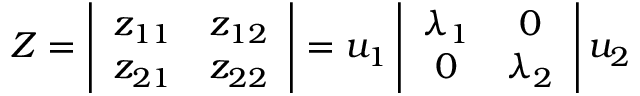<formula> <loc_0><loc_0><loc_500><loc_500>Z = \left | \begin{array} { c c } { { z _ { 1 1 } } } & { { z _ { 1 2 } } } \\ { { z _ { 2 1 } } } & { { z _ { 2 2 } } } \end{array} \right | = u _ { 1 } \left | \begin{array} { c c } { { \lambda _ { 1 } } } & { 0 } \\ { 0 } & { { \lambda _ { 2 } } } \end{array} \right | u _ { 2 }</formula> 